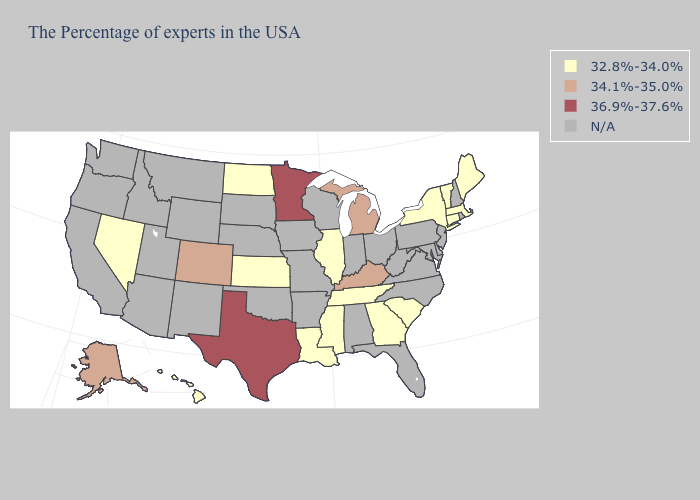Does Texas have the highest value in the USA?
Be succinct. Yes. What is the value of Connecticut?
Give a very brief answer. 32.8%-34.0%. Among the states that border Wisconsin , does Minnesota have the highest value?
Quick response, please. Yes. Among the states that border Mississippi , which have the lowest value?
Keep it brief. Tennessee, Louisiana. What is the value of Mississippi?
Concise answer only. 32.8%-34.0%. What is the lowest value in states that border South Dakota?
Write a very short answer. 32.8%-34.0%. What is the lowest value in states that border Oregon?
Quick response, please. 32.8%-34.0%. Does the first symbol in the legend represent the smallest category?
Write a very short answer. Yes. Name the states that have a value in the range 36.9%-37.6%?
Be succinct. Minnesota, Texas. Name the states that have a value in the range 34.1%-35.0%?
Short answer required. Michigan, Kentucky, Colorado, Alaska. What is the value of Massachusetts?
Short answer required. 32.8%-34.0%. 